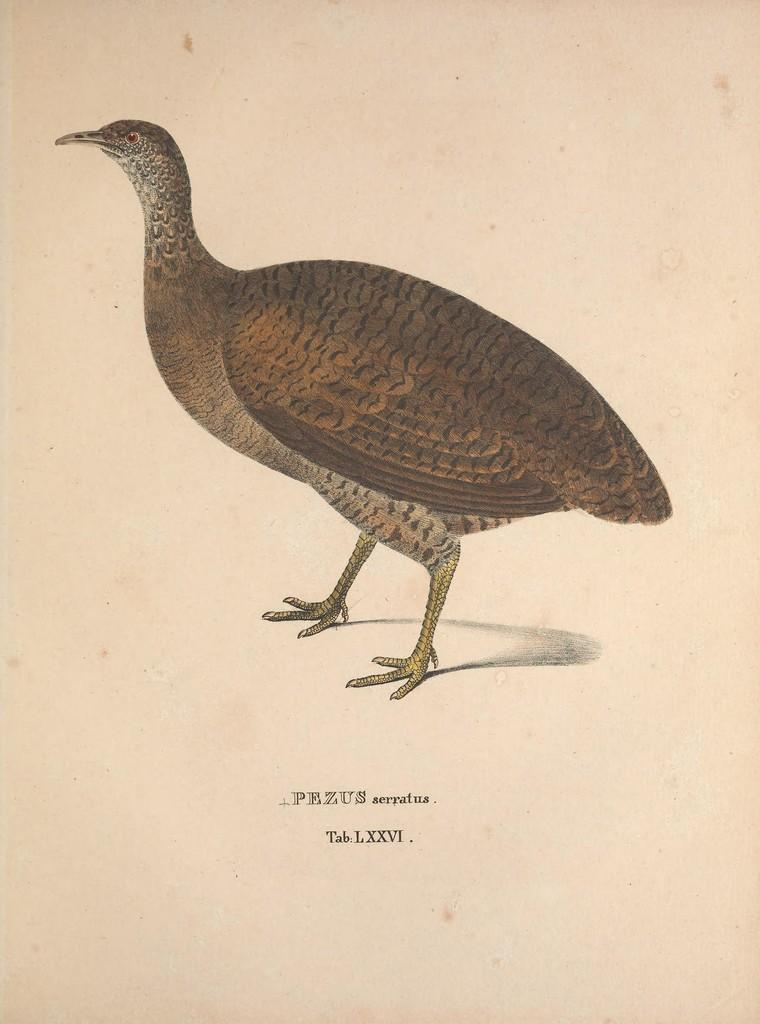What is depicted on the paper in the image? There is a drawing of a bird on the paper. What else can be seen on the paper besides the drawing? There is text on the paper. What type of cabbage is being stored in the jail in the image? There is no jail or cabbage present in the image; it only features a drawing of a bird and text on a paper. 